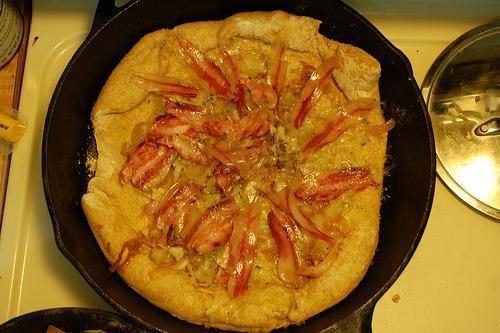How many lids are there?
Give a very brief answer. 1. How many pans are shown?
Give a very brief answer. 1. How many lids are shown?
Give a very brief answer. 1. 